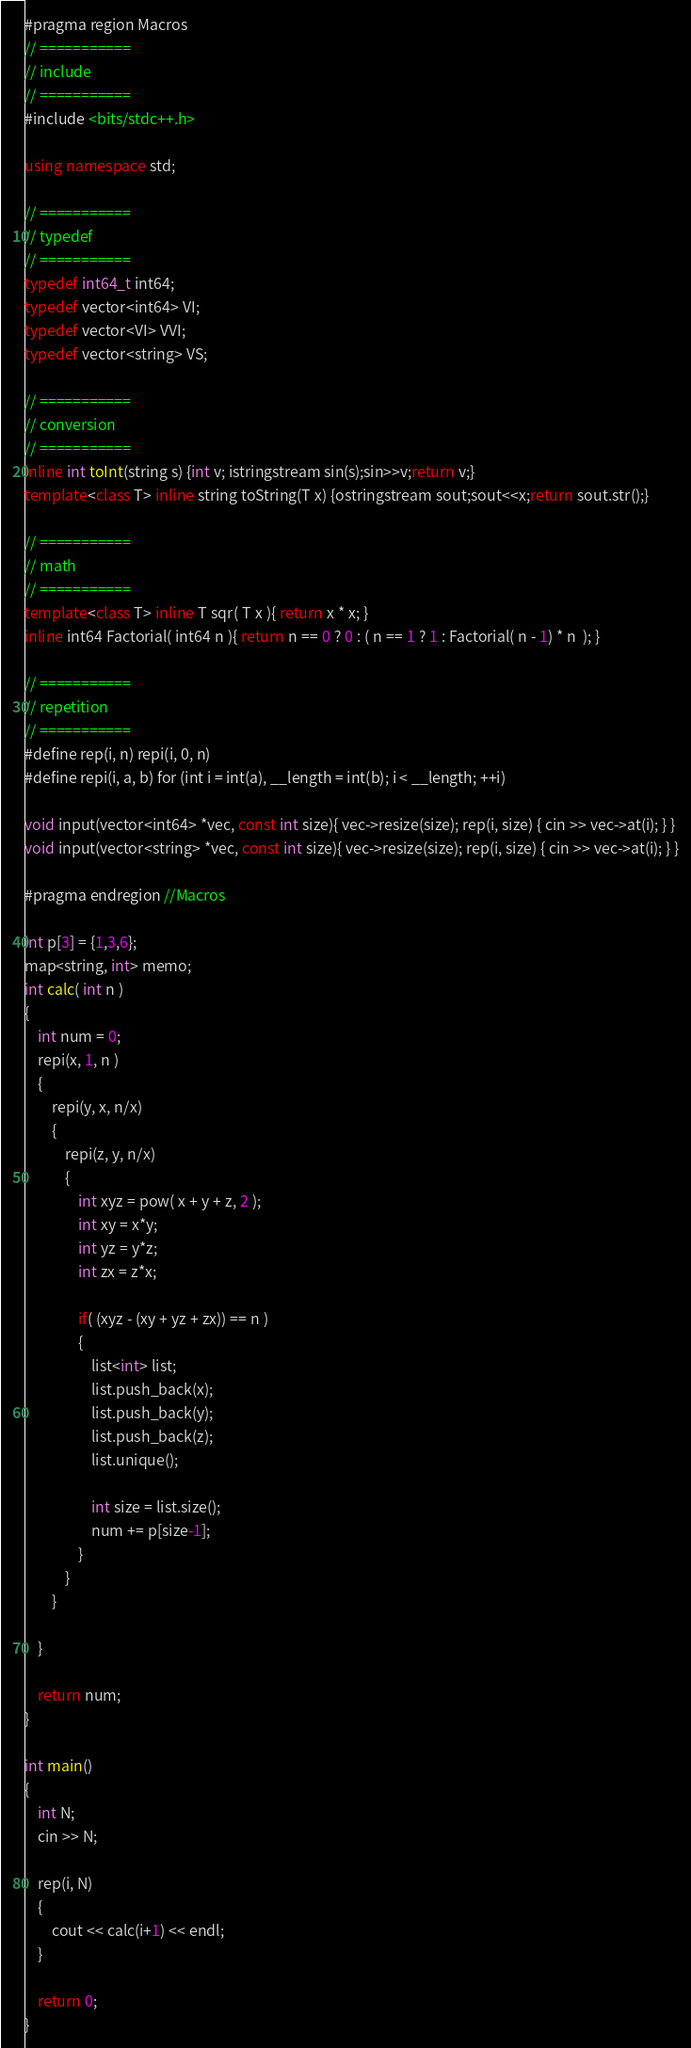Convert code to text. <code><loc_0><loc_0><loc_500><loc_500><_C++_>#pragma region Macros
// ===========
// include
// ===========
#include <bits/stdc++.h>

using namespace std;

// ===========
// typedef
// ===========
typedef int64_t int64;
typedef vector<int64> VI;
typedef vector<VI> VVI;
typedef vector<string> VS;

// ===========
// conversion
// ===========
inline int toInt(string s) {int v; istringstream sin(s);sin>>v;return v;}
template<class T> inline string toString(T x) {ostringstream sout;sout<<x;return sout.str();}

// ===========
// math
// ===========
template<class T> inline T sqr( T x ){ return x * x; }
inline int64 Factorial( int64 n ){ return n == 0 ? 0 : ( n == 1 ? 1 : Factorial( n - 1) * n  ); }

// ===========
// repetition
// ===========
#define rep(i, n) repi(i, 0, n)
#define repi(i, a, b) for (int i = int(a), __length = int(b); i < __length; ++i)

void input(vector<int64> *vec, const int size){ vec->resize(size); rep(i, size) { cin >> vec->at(i); } }
void input(vector<string> *vec, const int size){ vec->resize(size); rep(i, size) { cin >> vec->at(i); } }

#pragma endregion //Macros

int p[3] = {1,3,6};
map<string, int> memo;
int calc( int n )
{
    int num = 0;
    repi(x, 1, n )
    {
        repi(y, x, n/x)
        {
            repi(z, y, n/x)
            {
                int xyz = pow( x + y + z, 2 );
                int xy = x*y;
                int yz = y*z;
                int zx = z*x;

                if( (xyz - (xy + yz + zx)) == n )
                {
                    list<int> list;
                    list.push_back(x);
                    list.push_back(y);
                    list.push_back(z);
                    list.unique();

                    int size = list.size();
                    num += p[size-1];
                }
            }
        }

    }

    return num;
}

int main()
{
    int N;
    cin >> N;

    rep(i, N)
    {
        cout << calc(i+1) << endl;
    }

    return 0;
}
</code> 